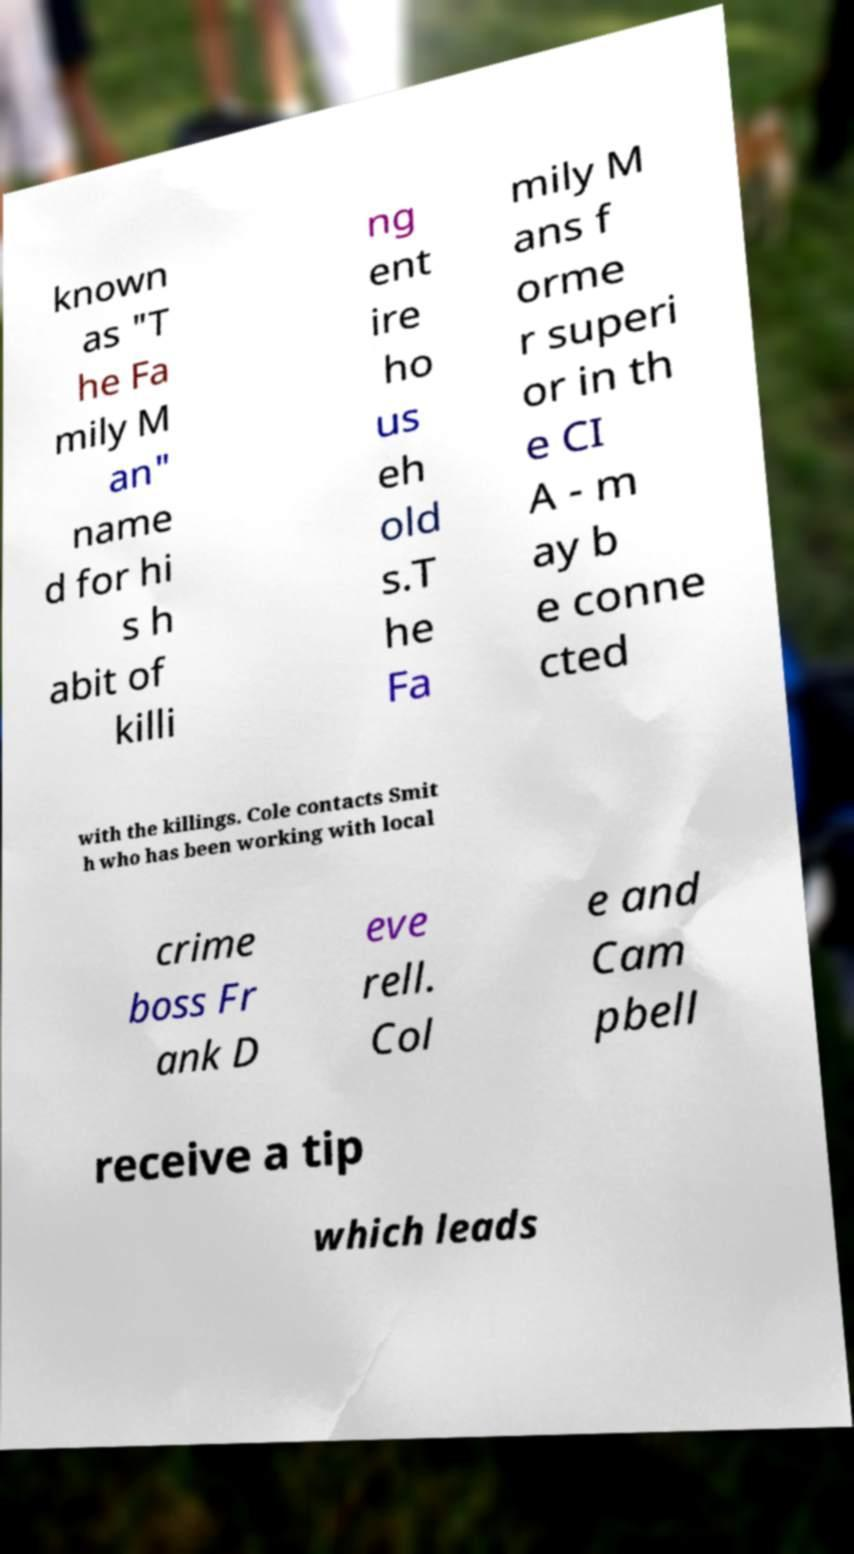Could you extract and type out the text from this image? known as "T he Fa mily M an" name d for hi s h abit of killi ng ent ire ho us eh old s.T he Fa mily M ans f orme r superi or in th e CI A - m ay b e conne cted with the killings. Cole contacts Smit h who has been working with local crime boss Fr ank D eve rell. Col e and Cam pbell receive a tip which leads 